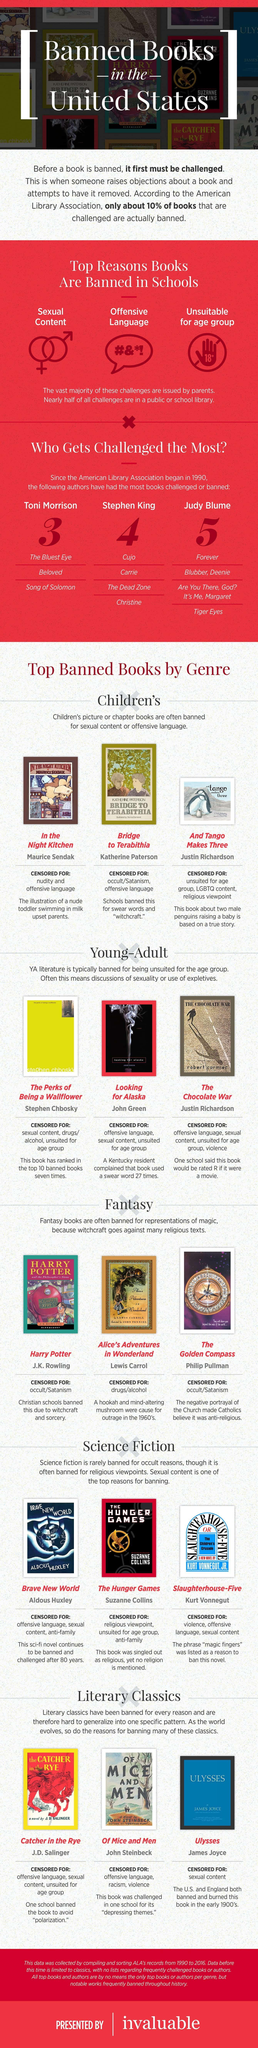which are the fantasy books given in this infographic that were banned because of occult/Satanism
Answer the question with a short phrase. Harry Potter, the golden compass what are the top reasons to ban a book in school? sexual content, offensive language, unsuitable for age group which are the banned books of Toni Morrison? the bluest eye, beloved, song of Solomon 